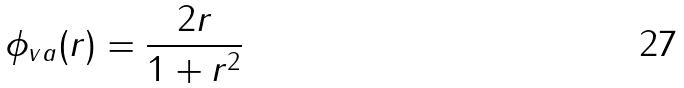<formula> <loc_0><loc_0><loc_500><loc_500>\phi _ { v a } ( r ) = \frac { 2 r } { 1 + r ^ { 2 } }</formula> 